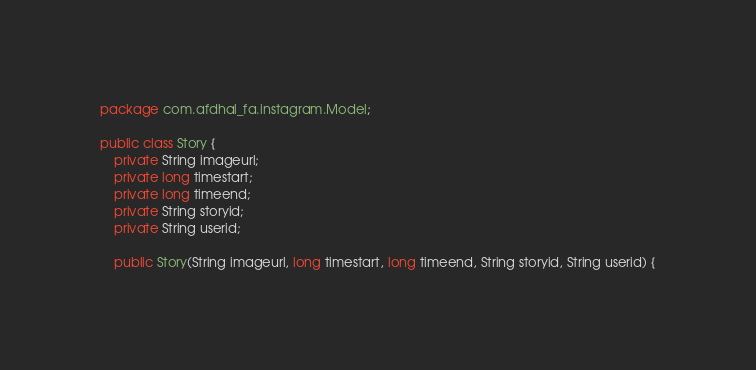Convert code to text. <code><loc_0><loc_0><loc_500><loc_500><_Java_>package com.afdhal_fa.instagram.Model;

public class Story {
    private String imageurl;
    private long timestart;
    private long timeend;
    private String storyid;
    private String userid;

    public Story(String imageurl, long timestart, long timeend, String storyid, String userid) {</code> 